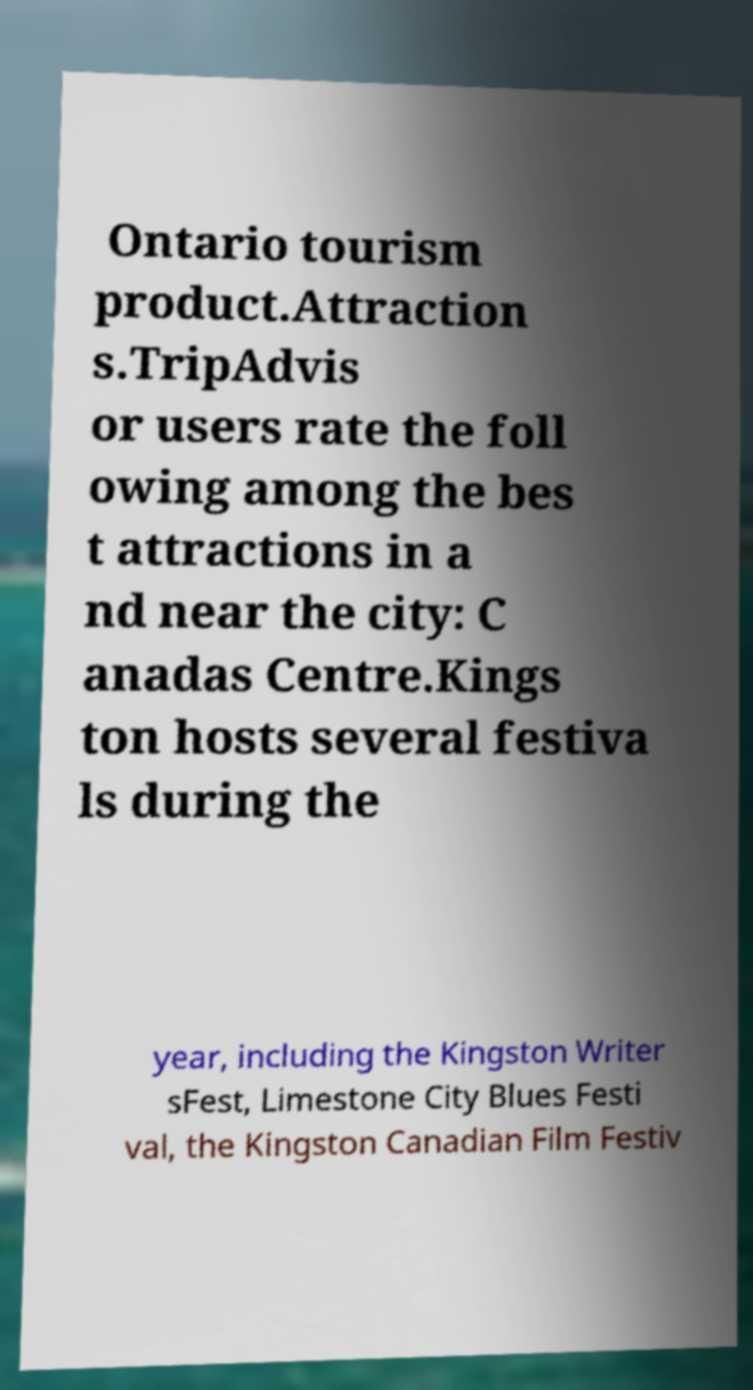What messages or text are displayed in this image? I need them in a readable, typed format. Ontario tourism product.Attraction s.TripAdvis or users rate the foll owing among the bes t attractions in a nd near the city: C anadas Centre.Kings ton hosts several festiva ls during the year, including the Kingston Writer sFest, Limestone City Blues Festi val, the Kingston Canadian Film Festiv 